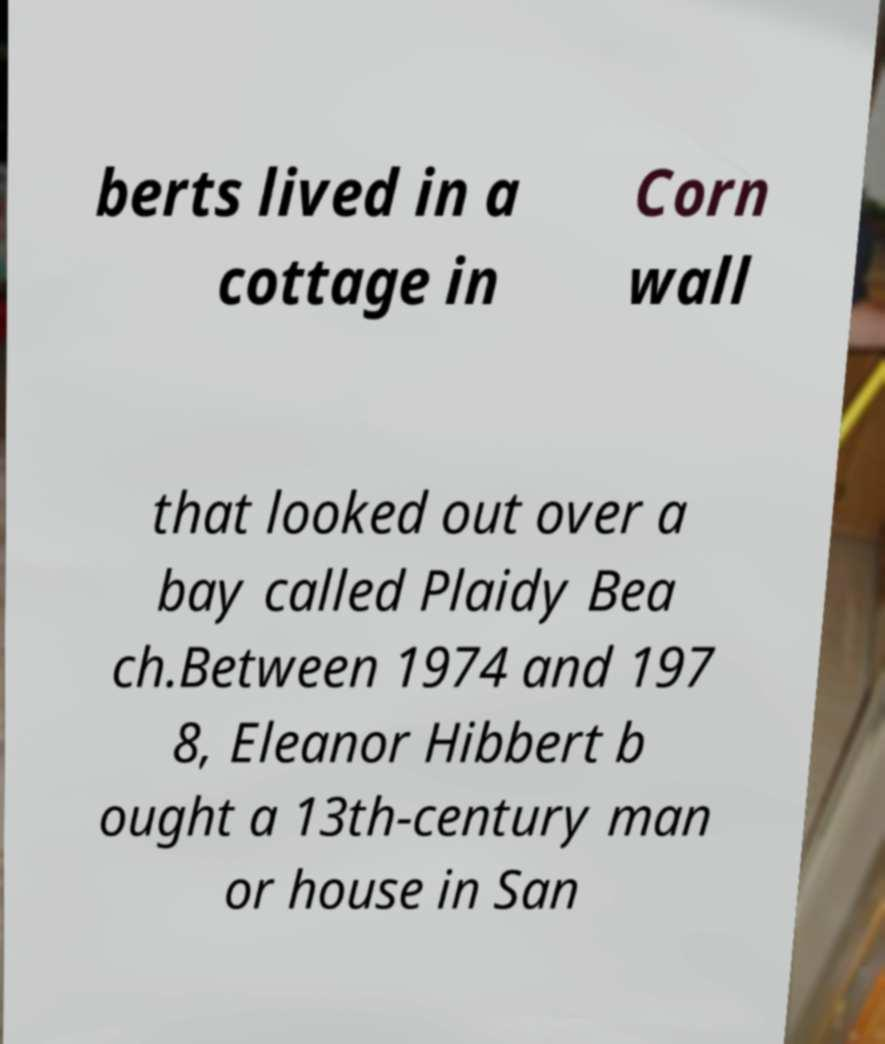There's text embedded in this image that I need extracted. Can you transcribe it verbatim? berts lived in a cottage in Corn wall that looked out over a bay called Plaidy Bea ch.Between 1974 and 197 8, Eleanor Hibbert b ought a 13th-century man or house in San 